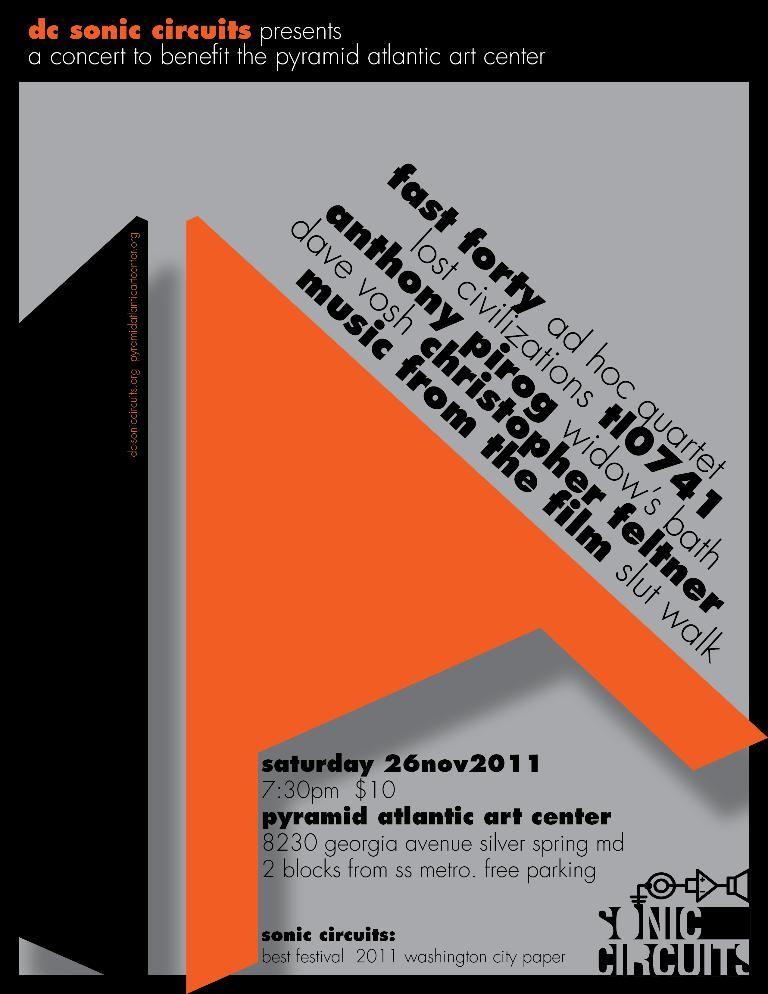<image>
Write a terse but informative summary of the picture. A poster for Sonic Circuits shows the cost as $10 per ticket 